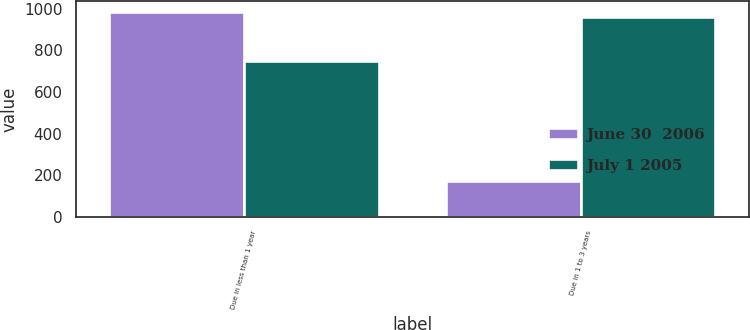Convert chart. <chart><loc_0><loc_0><loc_500><loc_500><stacked_bar_chart><ecel><fcel>Due in less than 1 year<fcel>Due in 1 to 3 years<nl><fcel>June 30  2006<fcel>986<fcel>175<nl><fcel>July 1 2005<fcel>748<fcel>960<nl></chart> 